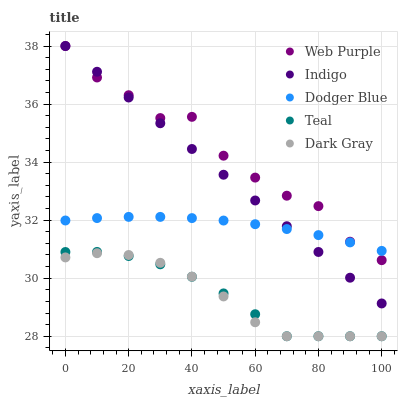Does Dark Gray have the minimum area under the curve?
Answer yes or no. Yes. Does Web Purple have the maximum area under the curve?
Answer yes or no. Yes. Does Dodger Blue have the minimum area under the curve?
Answer yes or no. No. Does Dodger Blue have the maximum area under the curve?
Answer yes or no. No. Is Indigo the smoothest?
Answer yes or no. Yes. Is Web Purple the roughest?
Answer yes or no. Yes. Is Dodger Blue the smoothest?
Answer yes or no. No. Is Dodger Blue the roughest?
Answer yes or no. No. Does Dark Gray have the lowest value?
Answer yes or no. Yes. Does Web Purple have the lowest value?
Answer yes or no. No. Does Indigo have the highest value?
Answer yes or no. Yes. Does Dodger Blue have the highest value?
Answer yes or no. No. Is Dark Gray less than Web Purple?
Answer yes or no. Yes. Is Dodger Blue greater than Dark Gray?
Answer yes or no. Yes. Does Teal intersect Dark Gray?
Answer yes or no. Yes. Is Teal less than Dark Gray?
Answer yes or no. No. Is Teal greater than Dark Gray?
Answer yes or no. No. Does Dark Gray intersect Web Purple?
Answer yes or no. No. 